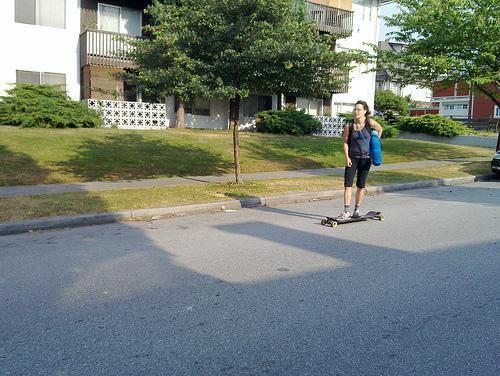How many women riding the skateboard?
Give a very brief answer. 1. 